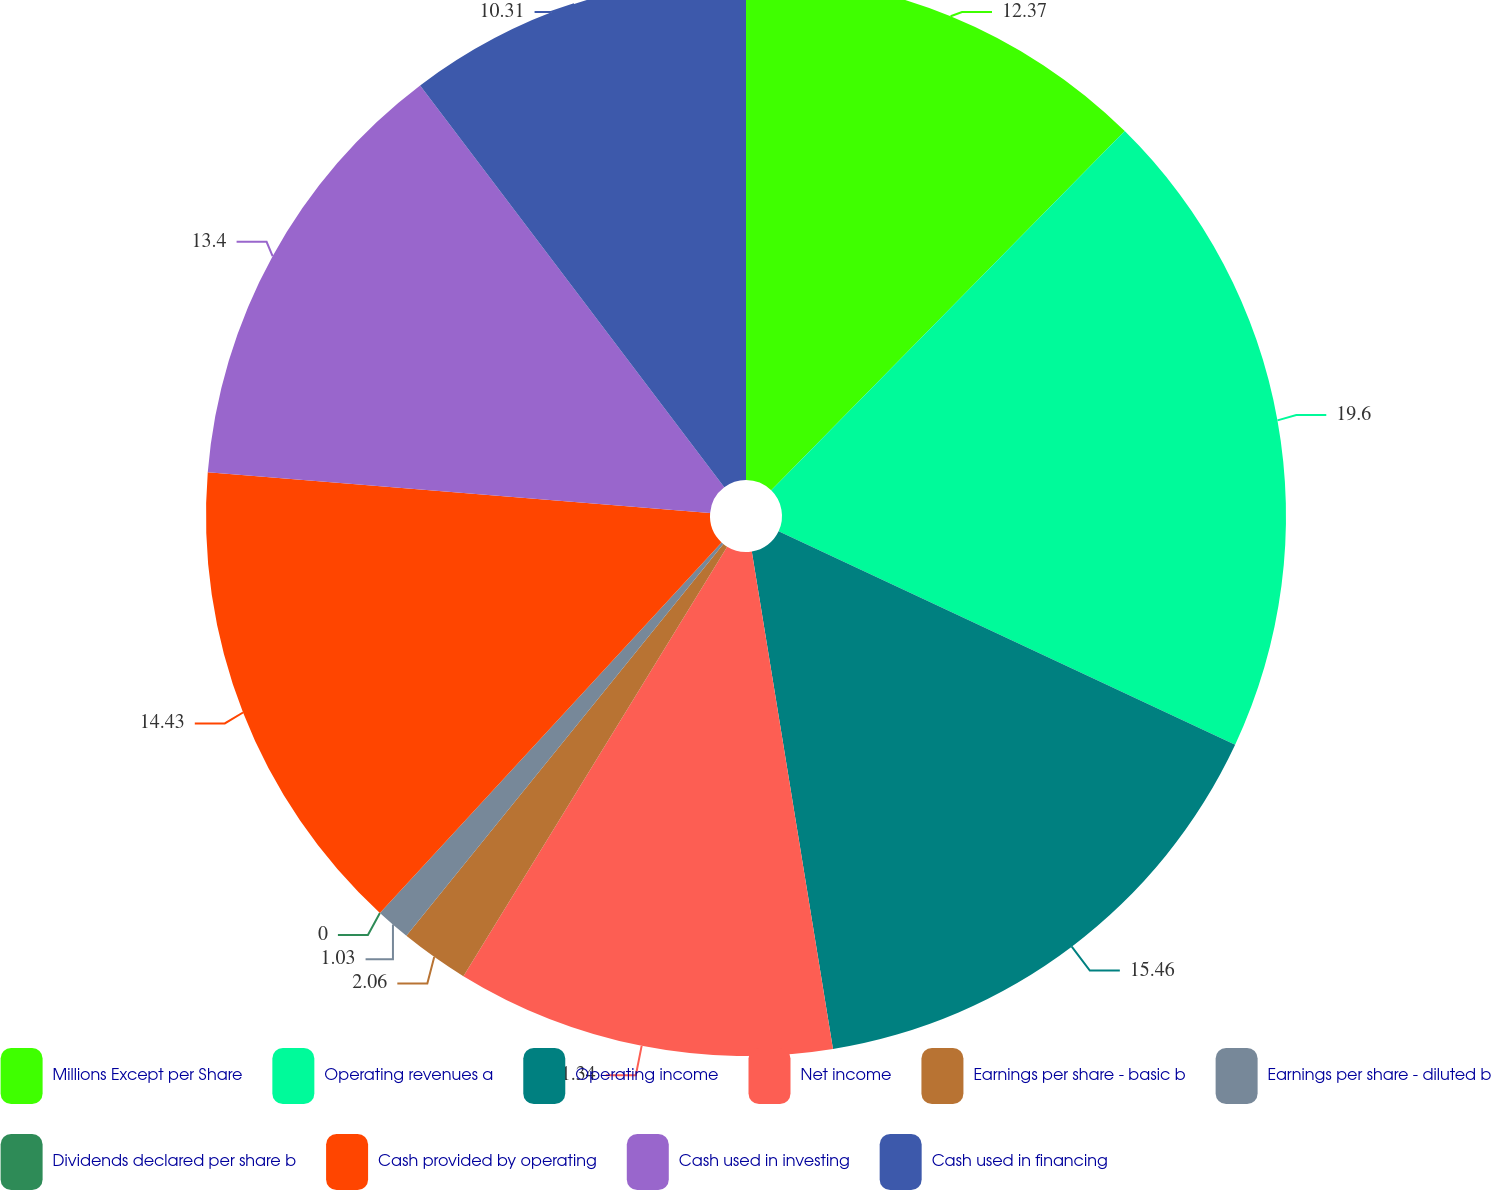<chart> <loc_0><loc_0><loc_500><loc_500><pie_chart><fcel>Millions Except per Share<fcel>Operating revenues a<fcel>Operating income<fcel>Net income<fcel>Earnings per share - basic b<fcel>Earnings per share - diluted b<fcel>Dividends declared per share b<fcel>Cash provided by operating<fcel>Cash used in investing<fcel>Cash used in financing<nl><fcel>12.37%<fcel>19.59%<fcel>15.46%<fcel>11.34%<fcel>2.06%<fcel>1.03%<fcel>0.0%<fcel>14.43%<fcel>13.4%<fcel>10.31%<nl></chart> 